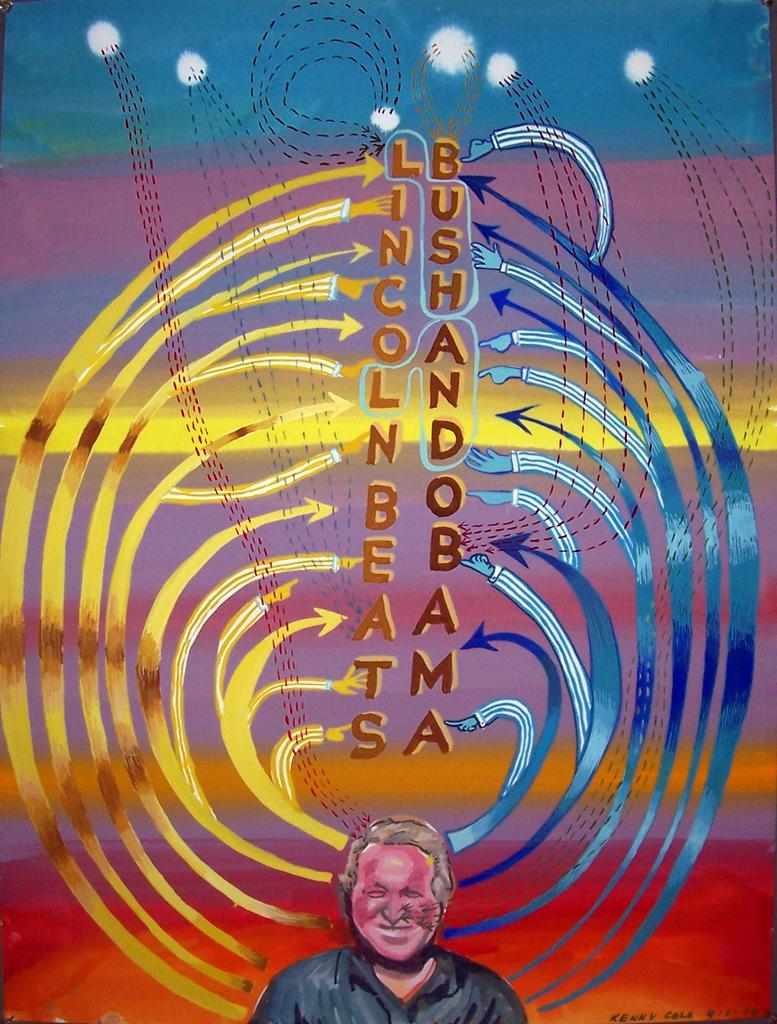What is the man in the image doing? The man is standing in the image. What is the man's facial expression in the image? The man is smiling in the image. What can be seen on the wall in the image? There is a decoration on the wall in the image. What type of apparel is the substance wearing in the image? There is no substance or apparel present in the image; it features a man standing and smiling. 